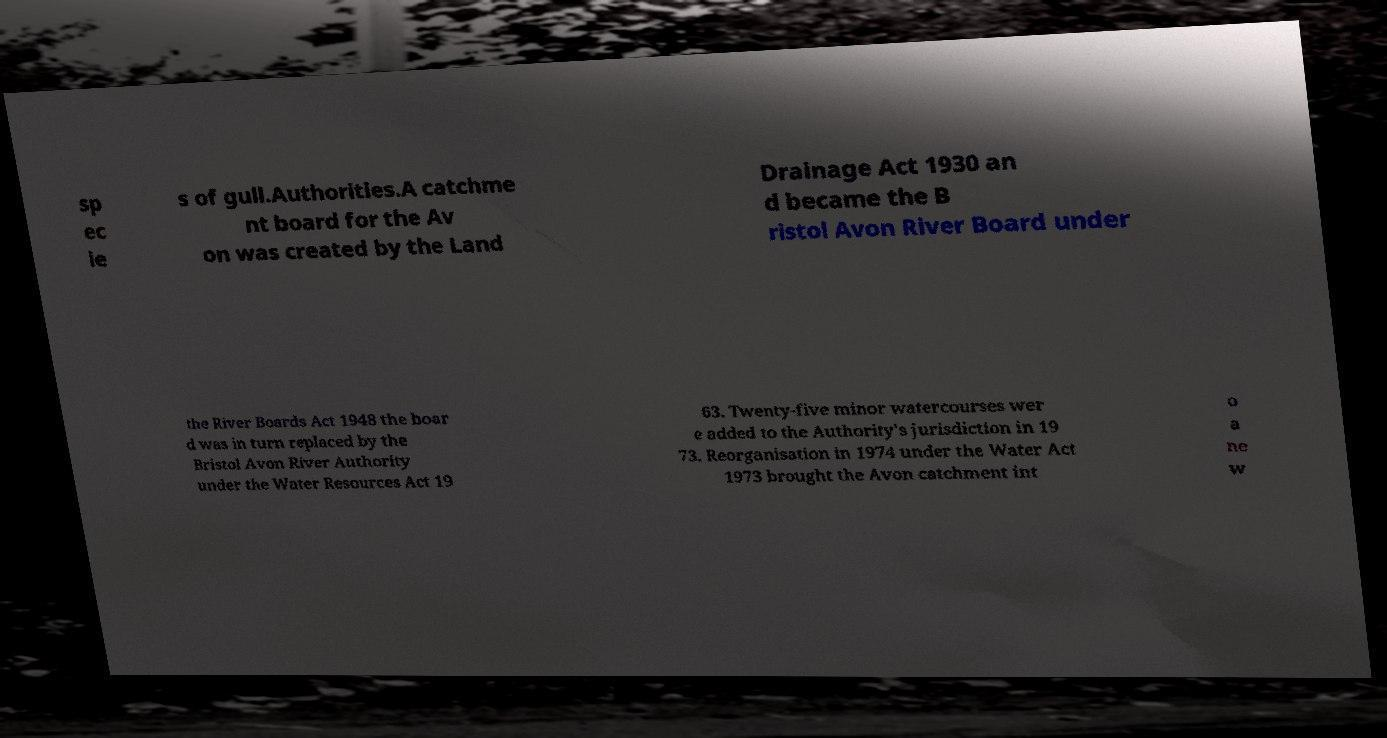Can you accurately transcribe the text from the provided image for me? sp ec ie s of gull.Authorities.A catchme nt board for the Av on was created by the Land Drainage Act 1930 an d became the B ristol Avon River Board under the River Boards Act 1948 the boar d was in turn replaced by the Bristol Avon River Authority under the Water Resources Act 19 63. Twenty-five minor watercourses wer e added to the Authority's jurisdiction in 19 73. Reorganisation in 1974 under the Water Act 1973 brought the Avon catchment int o a ne w 